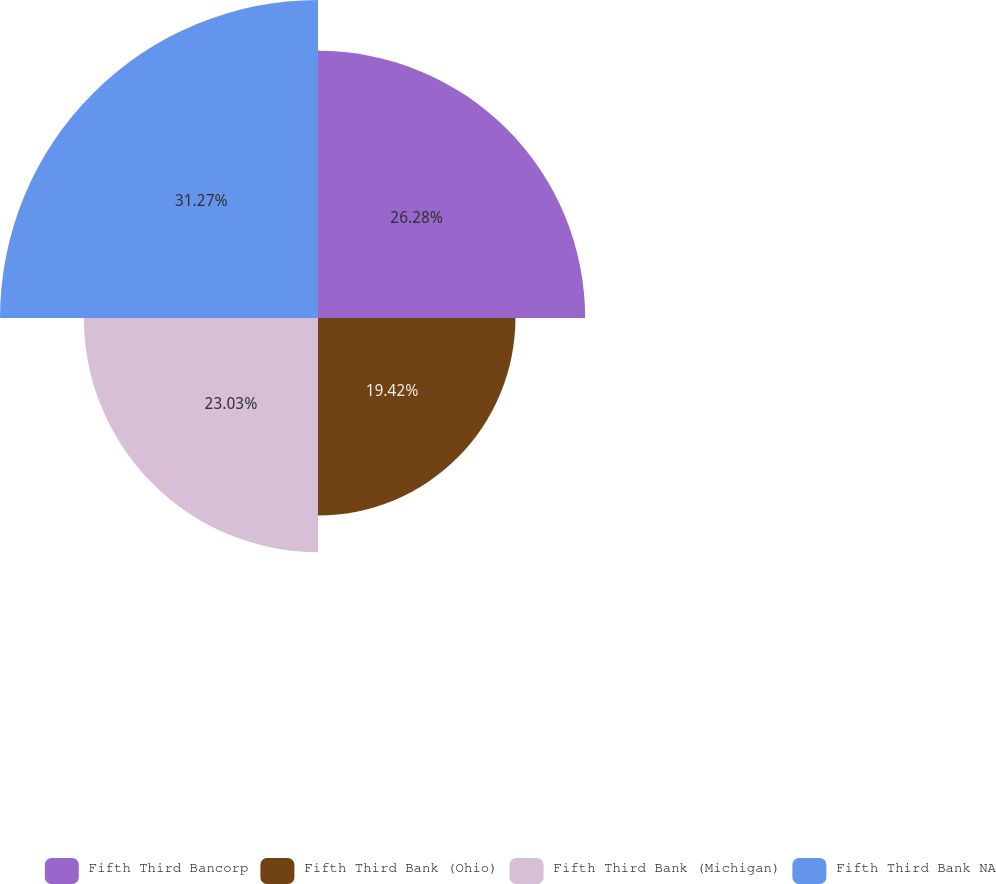<chart> <loc_0><loc_0><loc_500><loc_500><pie_chart><fcel>Fifth Third Bancorp<fcel>Fifth Third Bank (Ohio)<fcel>Fifth Third Bank (Michigan)<fcel>Fifth Third Bank NA<nl><fcel>26.28%<fcel>19.42%<fcel>23.03%<fcel>31.28%<nl></chart> 